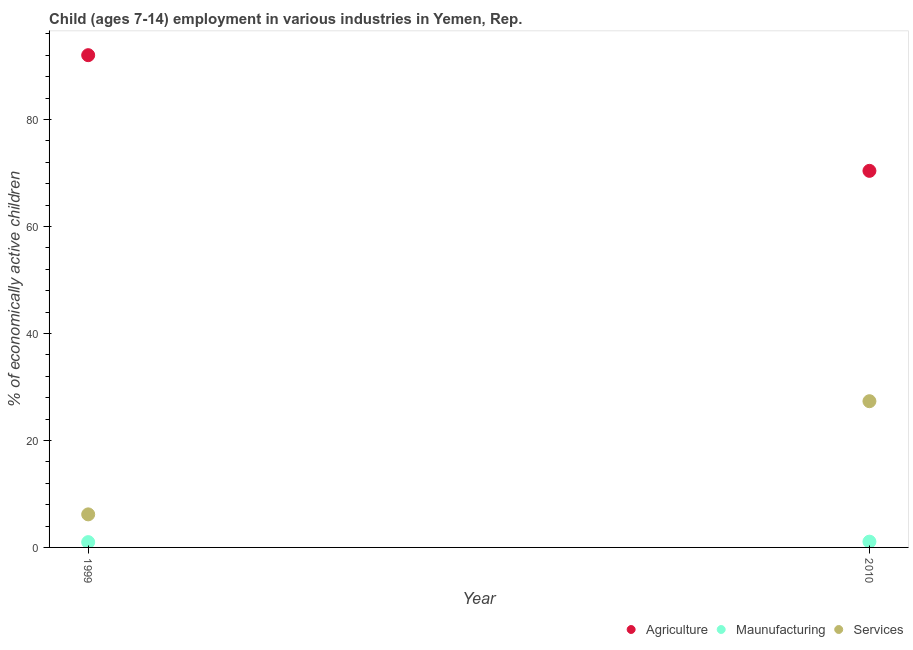How many different coloured dotlines are there?
Your answer should be compact. 3. Is the number of dotlines equal to the number of legend labels?
Offer a terse response. Yes. What is the percentage of economically active children in services in 1999?
Keep it short and to the point. 6.18. Across all years, what is the maximum percentage of economically active children in services?
Provide a succinct answer. 27.34. Across all years, what is the minimum percentage of economically active children in agriculture?
Give a very brief answer. 70.41. In which year was the percentage of economically active children in agriculture maximum?
Offer a terse response. 1999. What is the total percentage of economically active children in agriculture in the graph?
Ensure brevity in your answer.  162.45. What is the difference between the percentage of economically active children in manufacturing in 1999 and that in 2010?
Provide a succinct answer. -0.09. What is the difference between the percentage of economically active children in agriculture in 2010 and the percentage of economically active children in services in 1999?
Keep it short and to the point. 64.23. What is the average percentage of economically active children in services per year?
Make the answer very short. 16.76. In the year 1999, what is the difference between the percentage of economically active children in agriculture and percentage of economically active children in manufacturing?
Keep it short and to the point. 91.05. What is the ratio of the percentage of economically active children in manufacturing in 1999 to that in 2010?
Your answer should be compact. 0.92. Is the percentage of economically active children in agriculture in 1999 less than that in 2010?
Make the answer very short. No. In how many years, is the percentage of economically active children in agriculture greater than the average percentage of economically active children in agriculture taken over all years?
Give a very brief answer. 1. Does the percentage of economically active children in agriculture monotonically increase over the years?
Give a very brief answer. No. Is the percentage of economically active children in services strictly greater than the percentage of economically active children in manufacturing over the years?
Keep it short and to the point. Yes. How many dotlines are there?
Your answer should be very brief. 3. How many years are there in the graph?
Provide a succinct answer. 2. What is the difference between two consecutive major ticks on the Y-axis?
Provide a short and direct response. 20. Are the values on the major ticks of Y-axis written in scientific E-notation?
Ensure brevity in your answer.  No. Does the graph contain any zero values?
Keep it short and to the point. No. Does the graph contain grids?
Give a very brief answer. No. How many legend labels are there?
Keep it short and to the point. 3. What is the title of the graph?
Your answer should be compact. Child (ages 7-14) employment in various industries in Yemen, Rep. Does "Social Protection" appear as one of the legend labels in the graph?
Make the answer very short. No. What is the label or title of the X-axis?
Offer a very short reply. Year. What is the label or title of the Y-axis?
Offer a terse response. % of economically active children. What is the % of economically active children of Agriculture in 1999?
Keep it short and to the point. 92.04. What is the % of economically active children in Services in 1999?
Ensure brevity in your answer.  6.18. What is the % of economically active children in Agriculture in 2010?
Your response must be concise. 70.41. What is the % of economically active children in Services in 2010?
Provide a succinct answer. 27.34. Across all years, what is the maximum % of economically active children in Agriculture?
Make the answer very short. 92.04. Across all years, what is the maximum % of economically active children in Services?
Your response must be concise. 27.34. Across all years, what is the minimum % of economically active children of Agriculture?
Make the answer very short. 70.41. Across all years, what is the minimum % of economically active children of Services?
Keep it short and to the point. 6.18. What is the total % of economically active children of Agriculture in the graph?
Ensure brevity in your answer.  162.45. What is the total % of economically active children in Maunufacturing in the graph?
Give a very brief answer. 2.07. What is the total % of economically active children of Services in the graph?
Make the answer very short. 33.52. What is the difference between the % of economically active children in Agriculture in 1999 and that in 2010?
Provide a succinct answer. 21.63. What is the difference between the % of economically active children of Maunufacturing in 1999 and that in 2010?
Your answer should be compact. -0.09. What is the difference between the % of economically active children of Services in 1999 and that in 2010?
Your answer should be very brief. -21.16. What is the difference between the % of economically active children of Agriculture in 1999 and the % of economically active children of Maunufacturing in 2010?
Provide a succinct answer. 90.96. What is the difference between the % of economically active children in Agriculture in 1999 and the % of economically active children in Services in 2010?
Provide a succinct answer. 64.7. What is the difference between the % of economically active children in Maunufacturing in 1999 and the % of economically active children in Services in 2010?
Make the answer very short. -26.35. What is the average % of economically active children of Agriculture per year?
Offer a terse response. 81.22. What is the average % of economically active children of Maunufacturing per year?
Make the answer very short. 1.03. What is the average % of economically active children of Services per year?
Ensure brevity in your answer.  16.76. In the year 1999, what is the difference between the % of economically active children in Agriculture and % of economically active children in Maunufacturing?
Provide a succinct answer. 91.05. In the year 1999, what is the difference between the % of economically active children in Agriculture and % of economically active children in Services?
Your response must be concise. 85.86. In the year 1999, what is the difference between the % of economically active children in Maunufacturing and % of economically active children in Services?
Ensure brevity in your answer.  -5.19. In the year 2010, what is the difference between the % of economically active children of Agriculture and % of economically active children of Maunufacturing?
Give a very brief answer. 69.33. In the year 2010, what is the difference between the % of economically active children of Agriculture and % of economically active children of Services?
Provide a short and direct response. 43.07. In the year 2010, what is the difference between the % of economically active children in Maunufacturing and % of economically active children in Services?
Provide a succinct answer. -26.26. What is the ratio of the % of economically active children of Agriculture in 1999 to that in 2010?
Make the answer very short. 1.31. What is the ratio of the % of economically active children in Maunufacturing in 1999 to that in 2010?
Offer a terse response. 0.92. What is the ratio of the % of economically active children of Services in 1999 to that in 2010?
Offer a very short reply. 0.23. What is the difference between the highest and the second highest % of economically active children in Agriculture?
Provide a short and direct response. 21.63. What is the difference between the highest and the second highest % of economically active children of Maunufacturing?
Provide a short and direct response. 0.09. What is the difference between the highest and the second highest % of economically active children in Services?
Ensure brevity in your answer.  21.16. What is the difference between the highest and the lowest % of economically active children of Agriculture?
Ensure brevity in your answer.  21.63. What is the difference between the highest and the lowest % of economically active children of Maunufacturing?
Your answer should be very brief. 0.09. What is the difference between the highest and the lowest % of economically active children of Services?
Ensure brevity in your answer.  21.16. 